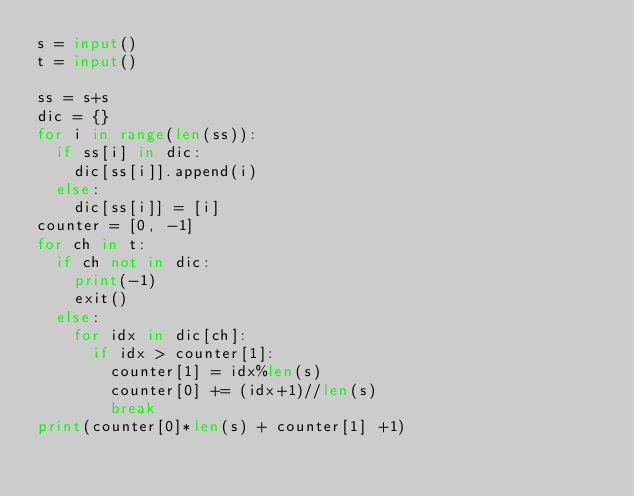Convert code to text. <code><loc_0><loc_0><loc_500><loc_500><_Python_>s = input()
t = input()

ss = s+s
dic = {}
for i in range(len(ss)):
  if ss[i] in dic:
    dic[ss[i]].append(i)
  else:
    dic[ss[i]] = [i]
counter = [0, -1]
for ch in t:
  if ch not in dic:
    print(-1)
    exit()
  else:
    for idx in dic[ch]:
      if idx > counter[1]:
        counter[1] = idx%len(s)
        counter[0] += (idx+1)//len(s)
        break
print(counter[0]*len(s) + counter[1] +1)</code> 